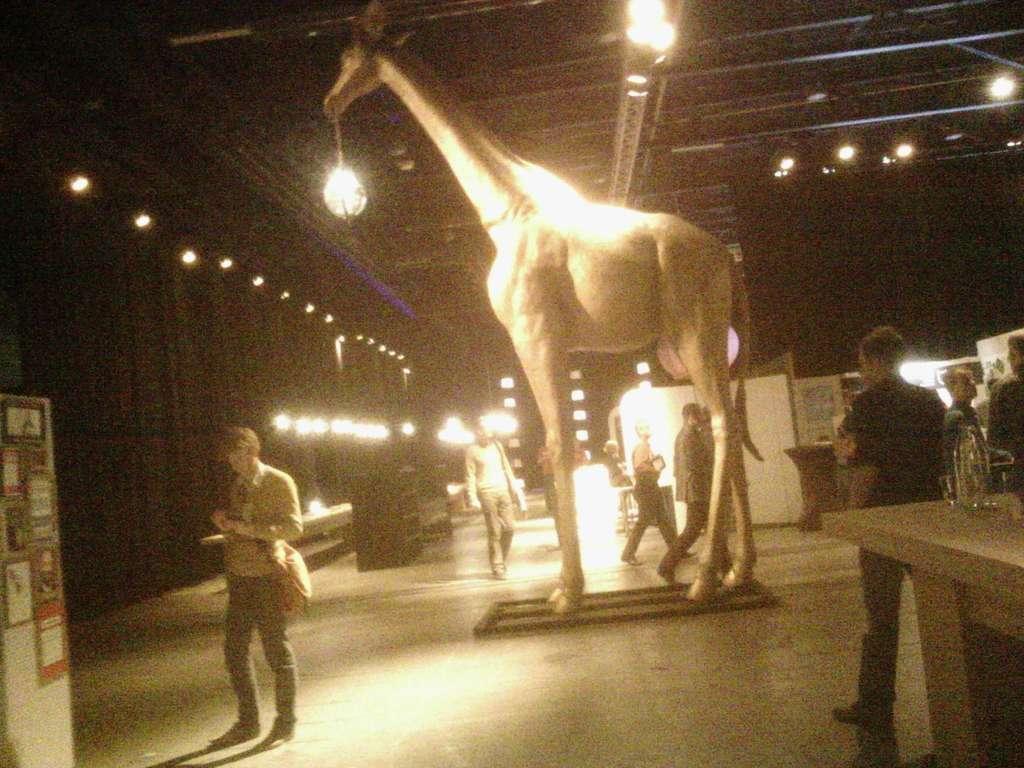In one or two sentences, can you explain what this image depicts? The picture is taken inside a building. There are few people here. On the roof there are lights. On the bottom left there is a board. This is a statue of giraffe. This is a table. 